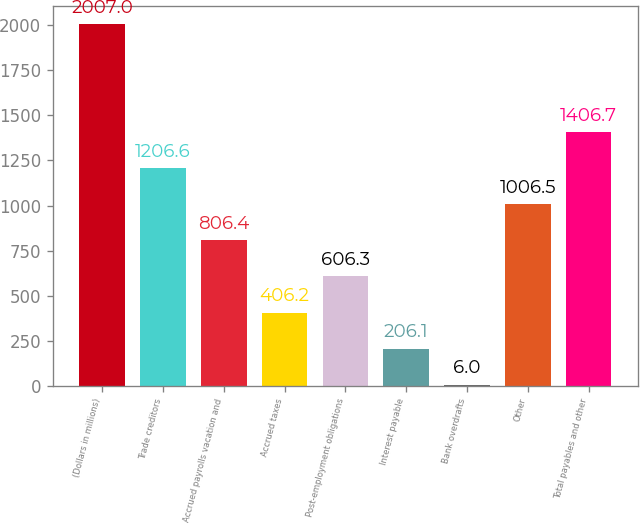<chart> <loc_0><loc_0><loc_500><loc_500><bar_chart><fcel>(Dollars in millions)<fcel>Trade creditors<fcel>Accrued payrolls vacation and<fcel>Accrued taxes<fcel>Post-employment obligations<fcel>Interest payable<fcel>Bank overdrafts<fcel>Other<fcel>Total payables and other<nl><fcel>2007<fcel>1206.6<fcel>806.4<fcel>406.2<fcel>606.3<fcel>206.1<fcel>6<fcel>1006.5<fcel>1406.7<nl></chart> 